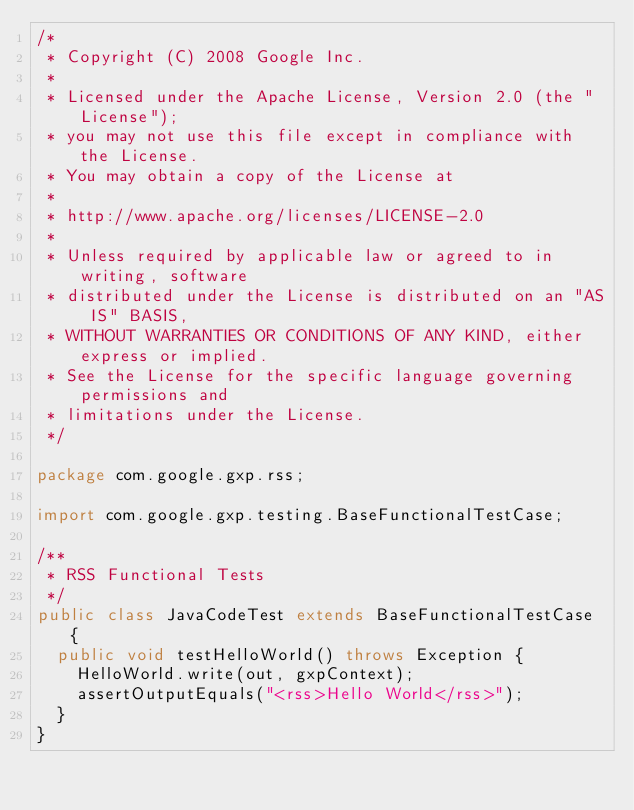<code> <loc_0><loc_0><loc_500><loc_500><_Java_>/*
 * Copyright (C) 2008 Google Inc.
 *
 * Licensed under the Apache License, Version 2.0 (the "License");
 * you may not use this file except in compliance with the License.
 * You may obtain a copy of the License at
 *
 * http://www.apache.org/licenses/LICENSE-2.0
 *
 * Unless required by applicable law or agreed to in writing, software
 * distributed under the License is distributed on an "AS IS" BASIS,
 * WITHOUT WARRANTIES OR CONDITIONS OF ANY KIND, either express or implied.
 * See the License for the specific language governing permissions and
 * limitations under the License.
 */

package com.google.gxp.rss;

import com.google.gxp.testing.BaseFunctionalTestCase;

/**
 * RSS Functional Tests
 */
public class JavaCodeTest extends BaseFunctionalTestCase {
  public void testHelloWorld() throws Exception {
    HelloWorld.write(out, gxpContext);
    assertOutputEquals("<rss>Hello World</rss>");
  }
}
</code> 